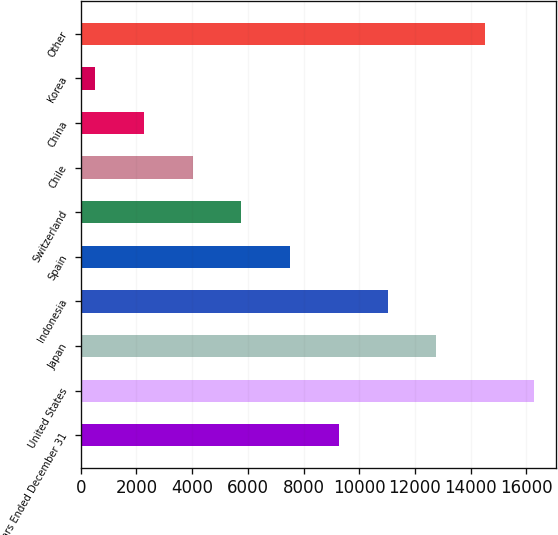Convert chart. <chart><loc_0><loc_0><loc_500><loc_500><bar_chart><fcel>Years Ended December 31<fcel>United States<fcel>Japan<fcel>Indonesia<fcel>Spain<fcel>Switzerland<fcel>Chile<fcel>China<fcel>Korea<fcel>Other<nl><fcel>9267.5<fcel>16261.5<fcel>12764.5<fcel>11016<fcel>7519<fcel>5770.5<fcel>4022<fcel>2273.5<fcel>525<fcel>14513<nl></chart> 